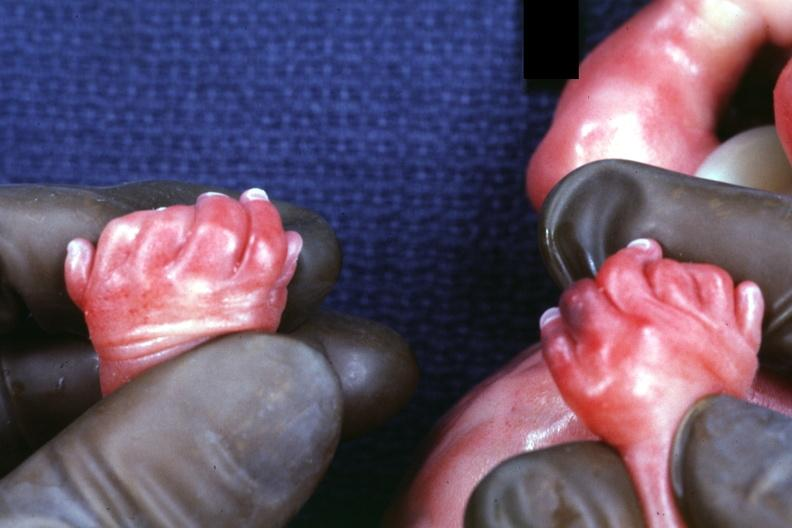does opened muscle have polycystic disease?
Answer the question using a single word or phrase. No 